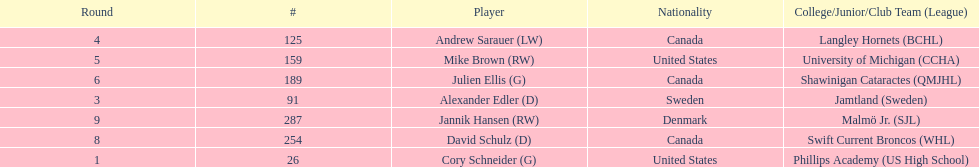The first round not to have a draft pick. 2. 